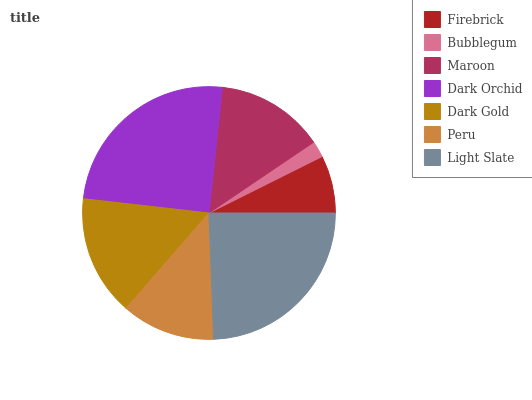Is Bubblegum the minimum?
Answer yes or no. Yes. Is Dark Orchid the maximum?
Answer yes or no. Yes. Is Maroon the minimum?
Answer yes or no. No. Is Maroon the maximum?
Answer yes or no. No. Is Maroon greater than Bubblegum?
Answer yes or no. Yes. Is Bubblegum less than Maroon?
Answer yes or no. Yes. Is Bubblegum greater than Maroon?
Answer yes or no. No. Is Maroon less than Bubblegum?
Answer yes or no. No. Is Maroon the high median?
Answer yes or no. Yes. Is Maroon the low median?
Answer yes or no. Yes. Is Bubblegum the high median?
Answer yes or no. No. Is Bubblegum the low median?
Answer yes or no. No. 